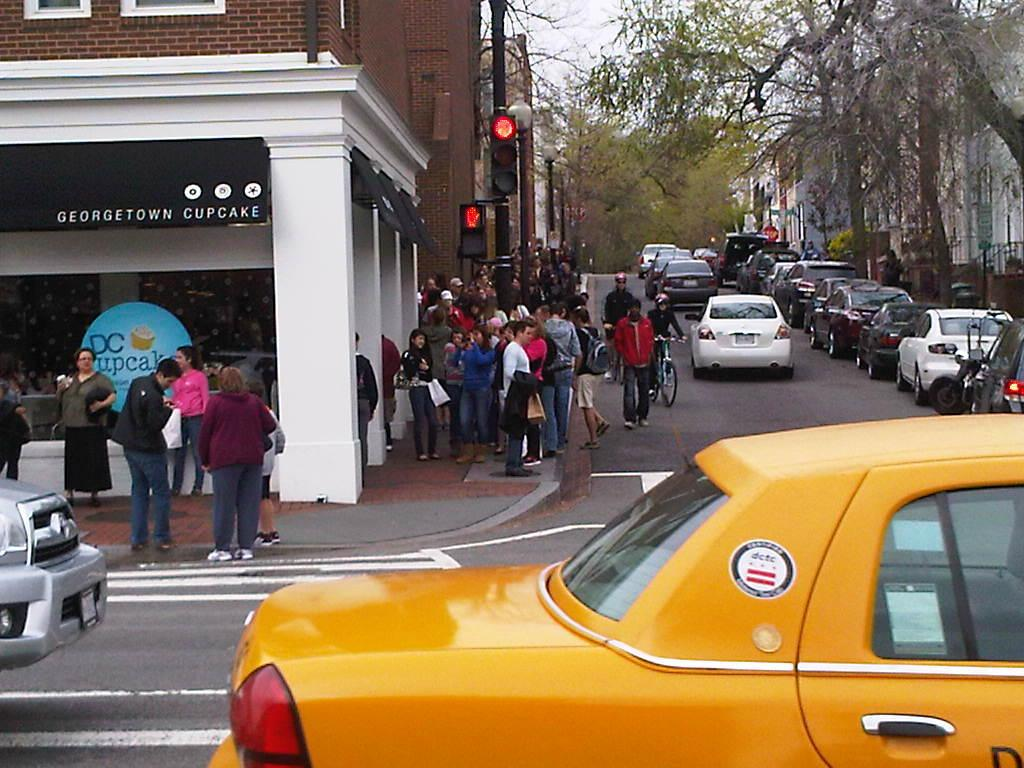<image>
Describe the image concisely. A crowd of people is shown standing outside of the Georgetown Cupcake store. 